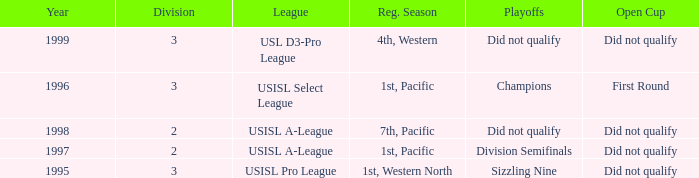Could you parse the entire table? {'header': ['Year', 'Division', 'League', 'Reg. Season', 'Playoffs', 'Open Cup'], 'rows': [['1999', '3', 'USL D3-Pro League', '4th, Western', 'Did not qualify', 'Did not qualify'], ['1996', '3', 'USISL Select League', '1st, Pacific', 'Champions', 'First Round'], ['1998', '2', 'USISL A-League', '7th, Pacific', 'Did not qualify', 'Did not qualify'], ['1997', '2', 'USISL A-League', '1st, Pacific', 'Division Semifinals', 'Did not qualify'], ['1995', '3', 'USISL Pro League', '1st, Western North', 'Sizzling Nine', 'Did not qualify']]} How many years was there a team that was part of the usisl pro league? 1.0. 